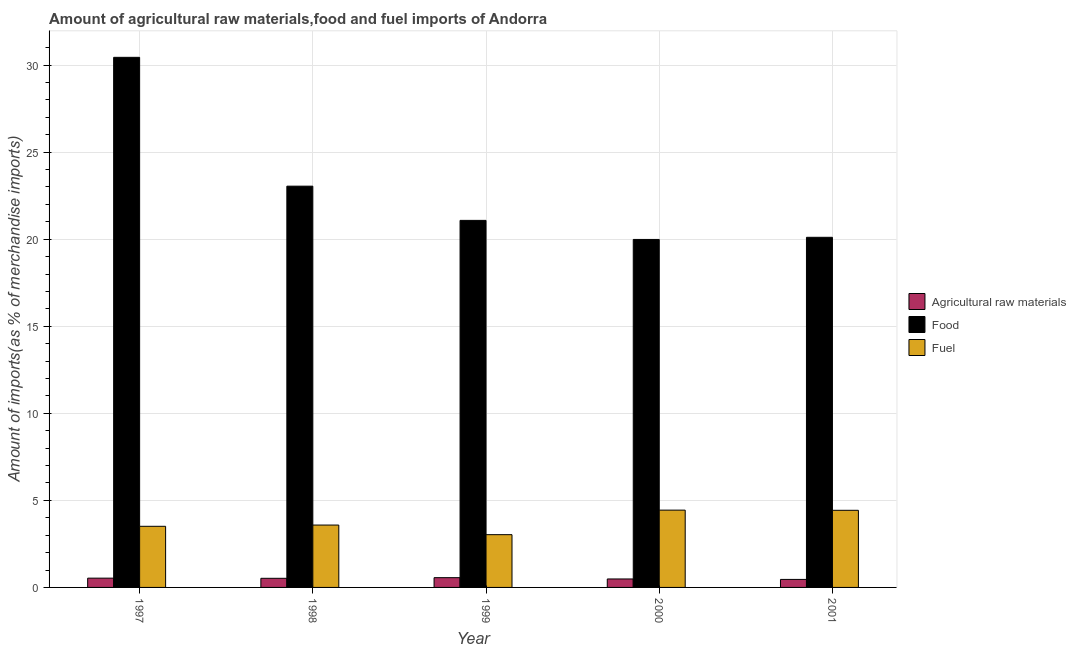How many bars are there on the 3rd tick from the left?
Provide a succinct answer. 3. In how many cases, is the number of bars for a given year not equal to the number of legend labels?
Your response must be concise. 0. What is the percentage of raw materials imports in 2000?
Make the answer very short. 0.49. Across all years, what is the maximum percentage of raw materials imports?
Provide a short and direct response. 0.56. Across all years, what is the minimum percentage of raw materials imports?
Your response must be concise. 0.46. In which year was the percentage of fuel imports minimum?
Your response must be concise. 1999. What is the total percentage of food imports in the graph?
Provide a short and direct response. 114.67. What is the difference between the percentage of raw materials imports in 1999 and that in 2000?
Provide a succinct answer. 0.07. What is the difference between the percentage of raw materials imports in 2000 and the percentage of fuel imports in 1999?
Ensure brevity in your answer.  -0.07. What is the average percentage of fuel imports per year?
Your answer should be very brief. 3.8. In how many years, is the percentage of fuel imports greater than 28 %?
Keep it short and to the point. 0. What is the ratio of the percentage of fuel imports in 1998 to that in 2001?
Provide a succinct answer. 0.81. Is the percentage of raw materials imports in 1997 less than that in 2001?
Your response must be concise. No. What is the difference between the highest and the second highest percentage of raw materials imports?
Your answer should be very brief. 0.03. What is the difference between the highest and the lowest percentage of raw materials imports?
Ensure brevity in your answer.  0.1. In how many years, is the percentage of food imports greater than the average percentage of food imports taken over all years?
Give a very brief answer. 2. Is the sum of the percentage of food imports in 2000 and 2001 greater than the maximum percentage of raw materials imports across all years?
Offer a very short reply. Yes. What does the 3rd bar from the left in 1997 represents?
Provide a short and direct response. Fuel. What does the 1st bar from the right in 1999 represents?
Offer a terse response. Fuel. How many bars are there?
Your answer should be compact. 15. How many years are there in the graph?
Provide a short and direct response. 5. What is the difference between two consecutive major ticks on the Y-axis?
Offer a terse response. 5. Does the graph contain grids?
Your response must be concise. Yes. Where does the legend appear in the graph?
Provide a short and direct response. Center right. What is the title of the graph?
Offer a terse response. Amount of agricultural raw materials,food and fuel imports of Andorra. Does "Ages 0-14" appear as one of the legend labels in the graph?
Give a very brief answer. No. What is the label or title of the X-axis?
Make the answer very short. Year. What is the label or title of the Y-axis?
Make the answer very short. Amount of imports(as % of merchandise imports). What is the Amount of imports(as % of merchandise imports) of Agricultural raw materials in 1997?
Ensure brevity in your answer.  0.53. What is the Amount of imports(as % of merchandise imports) of Food in 1997?
Ensure brevity in your answer.  30.45. What is the Amount of imports(as % of merchandise imports) in Fuel in 1997?
Give a very brief answer. 3.51. What is the Amount of imports(as % of merchandise imports) in Agricultural raw materials in 1998?
Your response must be concise. 0.52. What is the Amount of imports(as % of merchandise imports) in Food in 1998?
Offer a very short reply. 23.05. What is the Amount of imports(as % of merchandise imports) of Fuel in 1998?
Ensure brevity in your answer.  3.58. What is the Amount of imports(as % of merchandise imports) in Agricultural raw materials in 1999?
Offer a terse response. 0.56. What is the Amount of imports(as % of merchandise imports) in Food in 1999?
Your response must be concise. 21.08. What is the Amount of imports(as % of merchandise imports) in Fuel in 1999?
Make the answer very short. 3.03. What is the Amount of imports(as % of merchandise imports) in Agricultural raw materials in 2000?
Your response must be concise. 0.49. What is the Amount of imports(as % of merchandise imports) of Food in 2000?
Your response must be concise. 19.99. What is the Amount of imports(as % of merchandise imports) of Fuel in 2000?
Provide a succinct answer. 4.44. What is the Amount of imports(as % of merchandise imports) in Agricultural raw materials in 2001?
Your response must be concise. 0.46. What is the Amount of imports(as % of merchandise imports) in Food in 2001?
Your answer should be compact. 20.11. What is the Amount of imports(as % of merchandise imports) in Fuel in 2001?
Keep it short and to the point. 4.43. Across all years, what is the maximum Amount of imports(as % of merchandise imports) of Agricultural raw materials?
Your response must be concise. 0.56. Across all years, what is the maximum Amount of imports(as % of merchandise imports) of Food?
Provide a succinct answer. 30.45. Across all years, what is the maximum Amount of imports(as % of merchandise imports) of Fuel?
Your answer should be compact. 4.44. Across all years, what is the minimum Amount of imports(as % of merchandise imports) in Agricultural raw materials?
Your answer should be very brief. 0.46. Across all years, what is the minimum Amount of imports(as % of merchandise imports) in Food?
Ensure brevity in your answer.  19.99. Across all years, what is the minimum Amount of imports(as % of merchandise imports) in Fuel?
Give a very brief answer. 3.03. What is the total Amount of imports(as % of merchandise imports) of Agricultural raw materials in the graph?
Provide a succinct answer. 2.56. What is the total Amount of imports(as % of merchandise imports) of Food in the graph?
Offer a terse response. 114.67. What is the total Amount of imports(as % of merchandise imports) in Fuel in the graph?
Offer a terse response. 18.99. What is the difference between the Amount of imports(as % of merchandise imports) in Agricultural raw materials in 1997 and that in 1998?
Provide a succinct answer. 0.01. What is the difference between the Amount of imports(as % of merchandise imports) in Food in 1997 and that in 1998?
Your response must be concise. 7.4. What is the difference between the Amount of imports(as % of merchandise imports) of Fuel in 1997 and that in 1998?
Give a very brief answer. -0.07. What is the difference between the Amount of imports(as % of merchandise imports) in Agricultural raw materials in 1997 and that in 1999?
Your response must be concise. -0.03. What is the difference between the Amount of imports(as % of merchandise imports) in Food in 1997 and that in 1999?
Offer a very short reply. 9.36. What is the difference between the Amount of imports(as % of merchandise imports) in Fuel in 1997 and that in 1999?
Keep it short and to the point. 0.48. What is the difference between the Amount of imports(as % of merchandise imports) in Agricultural raw materials in 1997 and that in 2000?
Provide a short and direct response. 0.05. What is the difference between the Amount of imports(as % of merchandise imports) in Food in 1997 and that in 2000?
Your answer should be very brief. 10.46. What is the difference between the Amount of imports(as % of merchandise imports) of Fuel in 1997 and that in 2000?
Your answer should be very brief. -0.93. What is the difference between the Amount of imports(as % of merchandise imports) in Agricultural raw materials in 1997 and that in 2001?
Provide a short and direct response. 0.07. What is the difference between the Amount of imports(as % of merchandise imports) in Food in 1997 and that in 2001?
Offer a terse response. 10.34. What is the difference between the Amount of imports(as % of merchandise imports) in Fuel in 1997 and that in 2001?
Keep it short and to the point. -0.92. What is the difference between the Amount of imports(as % of merchandise imports) of Agricultural raw materials in 1998 and that in 1999?
Keep it short and to the point. -0.04. What is the difference between the Amount of imports(as % of merchandise imports) of Food in 1998 and that in 1999?
Provide a short and direct response. 1.97. What is the difference between the Amount of imports(as % of merchandise imports) in Fuel in 1998 and that in 1999?
Provide a succinct answer. 0.55. What is the difference between the Amount of imports(as % of merchandise imports) in Agricultural raw materials in 1998 and that in 2000?
Offer a very short reply. 0.04. What is the difference between the Amount of imports(as % of merchandise imports) in Food in 1998 and that in 2000?
Provide a short and direct response. 3.06. What is the difference between the Amount of imports(as % of merchandise imports) in Fuel in 1998 and that in 2000?
Make the answer very short. -0.86. What is the difference between the Amount of imports(as % of merchandise imports) of Agricultural raw materials in 1998 and that in 2001?
Your answer should be very brief. 0.06. What is the difference between the Amount of imports(as % of merchandise imports) in Food in 1998 and that in 2001?
Provide a succinct answer. 2.94. What is the difference between the Amount of imports(as % of merchandise imports) of Fuel in 1998 and that in 2001?
Offer a terse response. -0.85. What is the difference between the Amount of imports(as % of merchandise imports) of Agricultural raw materials in 1999 and that in 2000?
Make the answer very short. 0.07. What is the difference between the Amount of imports(as % of merchandise imports) of Food in 1999 and that in 2000?
Ensure brevity in your answer.  1.09. What is the difference between the Amount of imports(as % of merchandise imports) in Fuel in 1999 and that in 2000?
Keep it short and to the point. -1.41. What is the difference between the Amount of imports(as % of merchandise imports) of Agricultural raw materials in 1999 and that in 2001?
Provide a short and direct response. 0.1. What is the difference between the Amount of imports(as % of merchandise imports) in Food in 1999 and that in 2001?
Provide a short and direct response. 0.97. What is the difference between the Amount of imports(as % of merchandise imports) in Fuel in 1999 and that in 2001?
Provide a succinct answer. -1.4. What is the difference between the Amount of imports(as % of merchandise imports) of Agricultural raw materials in 2000 and that in 2001?
Your answer should be compact. 0.03. What is the difference between the Amount of imports(as % of merchandise imports) of Food in 2000 and that in 2001?
Offer a very short reply. -0.12. What is the difference between the Amount of imports(as % of merchandise imports) in Fuel in 2000 and that in 2001?
Offer a very short reply. 0.01. What is the difference between the Amount of imports(as % of merchandise imports) in Agricultural raw materials in 1997 and the Amount of imports(as % of merchandise imports) in Food in 1998?
Your answer should be very brief. -22.51. What is the difference between the Amount of imports(as % of merchandise imports) in Agricultural raw materials in 1997 and the Amount of imports(as % of merchandise imports) in Fuel in 1998?
Provide a short and direct response. -3.05. What is the difference between the Amount of imports(as % of merchandise imports) in Food in 1997 and the Amount of imports(as % of merchandise imports) in Fuel in 1998?
Keep it short and to the point. 26.86. What is the difference between the Amount of imports(as % of merchandise imports) in Agricultural raw materials in 1997 and the Amount of imports(as % of merchandise imports) in Food in 1999?
Provide a short and direct response. -20.55. What is the difference between the Amount of imports(as % of merchandise imports) of Agricultural raw materials in 1997 and the Amount of imports(as % of merchandise imports) of Fuel in 1999?
Offer a terse response. -2.5. What is the difference between the Amount of imports(as % of merchandise imports) in Food in 1997 and the Amount of imports(as % of merchandise imports) in Fuel in 1999?
Provide a short and direct response. 27.41. What is the difference between the Amount of imports(as % of merchandise imports) of Agricultural raw materials in 1997 and the Amount of imports(as % of merchandise imports) of Food in 2000?
Make the answer very short. -19.45. What is the difference between the Amount of imports(as % of merchandise imports) of Agricultural raw materials in 1997 and the Amount of imports(as % of merchandise imports) of Fuel in 2000?
Provide a short and direct response. -3.91. What is the difference between the Amount of imports(as % of merchandise imports) of Food in 1997 and the Amount of imports(as % of merchandise imports) of Fuel in 2000?
Make the answer very short. 26.01. What is the difference between the Amount of imports(as % of merchandise imports) in Agricultural raw materials in 1997 and the Amount of imports(as % of merchandise imports) in Food in 2001?
Your answer should be very brief. -19.58. What is the difference between the Amount of imports(as % of merchandise imports) in Agricultural raw materials in 1997 and the Amount of imports(as % of merchandise imports) in Fuel in 2001?
Offer a terse response. -3.9. What is the difference between the Amount of imports(as % of merchandise imports) of Food in 1997 and the Amount of imports(as % of merchandise imports) of Fuel in 2001?
Make the answer very short. 26.02. What is the difference between the Amount of imports(as % of merchandise imports) of Agricultural raw materials in 1998 and the Amount of imports(as % of merchandise imports) of Food in 1999?
Your answer should be very brief. -20.56. What is the difference between the Amount of imports(as % of merchandise imports) in Agricultural raw materials in 1998 and the Amount of imports(as % of merchandise imports) in Fuel in 1999?
Keep it short and to the point. -2.51. What is the difference between the Amount of imports(as % of merchandise imports) of Food in 1998 and the Amount of imports(as % of merchandise imports) of Fuel in 1999?
Your answer should be very brief. 20.02. What is the difference between the Amount of imports(as % of merchandise imports) in Agricultural raw materials in 1998 and the Amount of imports(as % of merchandise imports) in Food in 2000?
Your answer should be very brief. -19.46. What is the difference between the Amount of imports(as % of merchandise imports) of Agricultural raw materials in 1998 and the Amount of imports(as % of merchandise imports) of Fuel in 2000?
Ensure brevity in your answer.  -3.92. What is the difference between the Amount of imports(as % of merchandise imports) of Food in 1998 and the Amount of imports(as % of merchandise imports) of Fuel in 2000?
Make the answer very short. 18.61. What is the difference between the Amount of imports(as % of merchandise imports) in Agricultural raw materials in 1998 and the Amount of imports(as % of merchandise imports) in Food in 2001?
Provide a succinct answer. -19.58. What is the difference between the Amount of imports(as % of merchandise imports) in Agricultural raw materials in 1998 and the Amount of imports(as % of merchandise imports) in Fuel in 2001?
Your answer should be compact. -3.91. What is the difference between the Amount of imports(as % of merchandise imports) of Food in 1998 and the Amount of imports(as % of merchandise imports) of Fuel in 2001?
Keep it short and to the point. 18.62. What is the difference between the Amount of imports(as % of merchandise imports) of Agricultural raw materials in 1999 and the Amount of imports(as % of merchandise imports) of Food in 2000?
Offer a very short reply. -19.43. What is the difference between the Amount of imports(as % of merchandise imports) of Agricultural raw materials in 1999 and the Amount of imports(as % of merchandise imports) of Fuel in 2000?
Your answer should be very brief. -3.88. What is the difference between the Amount of imports(as % of merchandise imports) in Food in 1999 and the Amount of imports(as % of merchandise imports) in Fuel in 2000?
Keep it short and to the point. 16.64. What is the difference between the Amount of imports(as % of merchandise imports) of Agricultural raw materials in 1999 and the Amount of imports(as % of merchandise imports) of Food in 2001?
Provide a short and direct response. -19.55. What is the difference between the Amount of imports(as % of merchandise imports) in Agricultural raw materials in 1999 and the Amount of imports(as % of merchandise imports) in Fuel in 2001?
Your response must be concise. -3.87. What is the difference between the Amount of imports(as % of merchandise imports) in Food in 1999 and the Amount of imports(as % of merchandise imports) in Fuel in 2001?
Keep it short and to the point. 16.65. What is the difference between the Amount of imports(as % of merchandise imports) of Agricultural raw materials in 2000 and the Amount of imports(as % of merchandise imports) of Food in 2001?
Provide a succinct answer. -19.62. What is the difference between the Amount of imports(as % of merchandise imports) of Agricultural raw materials in 2000 and the Amount of imports(as % of merchandise imports) of Fuel in 2001?
Your answer should be very brief. -3.94. What is the difference between the Amount of imports(as % of merchandise imports) in Food in 2000 and the Amount of imports(as % of merchandise imports) in Fuel in 2001?
Your response must be concise. 15.56. What is the average Amount of imports(as % of merchandise imports) in Agricultural raw materials per year?
Your answer should be very brief. 0.51. What is the average Amount of imports(as % of merchandise imports) of Food per year?
Your answer should be compact. 22.93. What is the average Amount of imports(as % of merchandise imports) in Fuel per year?
Offer a very short reply. 3.8. In the year 1997, what is the difference between the Amount of imports(as % of merchandise imports) of Agricultural raw materials and Amount of imports(as % of merchandise imports) of Food?
Your answer should be very brief. -29.91. In the year 1997, what is the difference between the Amount of imports(as % of merchandise imports) of Agricultural raw materials and Amount of imports(as % of merchandise imports) of Fuel?
Offer a terse response. -2.98. In the year 1997, what is the difference between the Amount of imports(as % of merchandise imports) in Food and Amount of imports(as % of merchandise imports) in Fuel?
Your response must be concise. 26.94. In the year 1998, what is the difference between the Amount of imports(as % of merchandise imports) of Agricultural raw materials and Amount of imports(as % of merchandise imports) of Food?
Provide a succinct answer. -22.52. In the year 1998, what is the difference between the Amount of imports(as % of merchandise imports) in Agricultural raw materials and Amount of imports(as % of merchandise imports) in Fuel?
Your answer should be compact. -3.06. In the year 1998, what is the difference between the Amount of imports(as % of merchandise imports) in Food and Amount of imports(as % of merchandise imports) in Fuel?
Offer a terse response. 19.46. In the year 1999, what is the difference between the Amount of imports(as % of merchandise imports) of Agricultural raw materials and Amount of imports(as % of merchandise imports) of Food?
Your answer should be compact. -20.52. In the year 1999, what is the difference between the Amount of imports(as % of merchandise imports) in Agricultural raw materials and Amount of imports(as % of merchandise imports) in Fuel?
Offer a very short reply. -2.47. In the year 1999, what is the difference between the Amount of imports(as % of merchandise imports) of Food and Amount of imports(as % of merchandise imports) of Fuel?
Keep it short and to the point. 18.05. In the year 2000, what is the difference between the Amount of imports(as % of merchandise imports) of Agricultural raw materials and Amount of imports(as % of merchandise imports) of Food?
Your response must be concise. -19.5. In the year 2000, what is the difference between the Amount of imports(as % of merchandise imports) of Agricultural raw materials and Amount of imports(as % of merchandise imports) of Fuel?
Provide a short and direct response. -3.95. In the year 2000, what is the difference between the Amount of imports(as % of merchandise imports) of Food and Amount of imports(as % of merchandise imports) of Fuel?
Give a very brief answer. 15.55. In the year 2001, what is the difference between the Amount of imports(as % of merchandise imports) of Agricultural raw materials and Amount of imports(as % of merchandise imports) of Food?
Keep it short and to the point. -19.65. In the year 2001, what is the difference between the Amount of imports(as % of merchandise imports) of Agricultural raw materials and Amount of imports(as % of merchandise imports) of Fuel?
Provide a succinct answer. -3.97. In the year 2001, what is the difference between the Amount of imports(as % of merchandise imports) of Food and Amount of imports(as % of merchandise imports) of Fuel?
Keep it short and to the point. 15.68. What is the ratio of the Amount of imports(as % of merchandise imports) in Agricultural raw materials in 1997 to that in 1998?
Give a very brief answer. 1.02. What is the ratio of the Amount of imports(as % of merchandise imports) in Food in 1997 to that in 1998?
Give a very brief answer. 1.32. What is the ratio of the Amount of imports(as % of merchandise imports) of Agricultural raw materials in 1997 to that in 1999?
Your answer should be compact. 0.95. What is the ratio of the Amount of imports(as % of merchandise imports) of Food in 1997 to that in 1999?
Keep it short and to the point. 1.44. What is the ratio of the Amount of imports(as % of merchandise imports) in Fuel in 1997 to that in 1999?
Keep it short and to the point. 1.16. What is the ratio of the Amount of imports(as % of merchandise imports) of Agricultural raw materials in 1997 to that in 2000?
Your response must be concise. 1.1. What is the ratio of the Amount of imports(as % of merchandise imports) of Food in 1997 to that in 2000?
Make the answer very short. 1.52. What is the ratio of the Amount of imports(as % of merchandise imports) of Fuel in 1997 to that in 2000?
Make the answer very short. 0.79. What is the ratio of the Amount of imports(as % of merchandise imports) of Agricultural raw materials in 1997 to that in 2001?
Your response must be concise. 1.16. What is the ratio of the Amount of imports(as % of merchandise imports) of Food in 1997 to that in 2001?
Ensure brevity in your answer.  1.51. What is the ratio of the Amount of imports(as % of merchandise imports) in Fuel in 1997 to that in 2001?
Provide a succinct answer. 0.79. What is the ratio of the Amount of imports(as % of merchandise imports) in Agricultural raw materials in 1998 to that in 1999?
Your answer should be very brief. 0.93. What is the ratio of the Amount of imports(as % of merchandise imports) in Food in 1998 to that in 1999?
Your answer should be compact. 1.09. What is the ratio of the Amount of imports(as % of merchandise imports) in Fuel in 1998 to that in 1999?
Your answer should be compact. 1.18. What is the ratio of the Amount of imports(as % of merchandise imports) of Agricultural raw materials in 1998 to that in 2000?
Your answer should be compact. 1.08. What is the ratio of the Amount of imports(as % of merchandise imports) of Food in 1998 to that in 2000?
Your answer should be compact. 1.15. What is the ratio of the Amount of imports(as % of merchandise imports) in Fuel in 1998 to that in 2000?
Offer a very short reply. 0.81. What is the ratio of the Amount of imports(as % of merchandise imports) in Agricultural raw materials in 1998 to that in 2001?
Keep it short and to the point. 1.14. What is the ratio of the Amount of imports(as % of merchandise imports) in Food in 1998 to that in 2001?
Your response must be concise. 1.15. What is the ratio of the Amount of imports(as % of merchandise imports) of Fuel in 1998 to that in 2001?
Your answer should be compact. 0.81. What is the ratio of the Amount of imports(as % of merchandise imports) of Agricultural raw materials in 1999 to that in 2000?
Give a very brief answer. 1.15. What is the ratio of the Amount of imports(as % of merchandise imports) in Food in 1999 to that in 2000?
Keep it short and to the point. 1.05. What is the ratio of the Amount of imports(as % of merchandise imports) of Fuel in 1999 to that in 2000?
Ensure brevity in your answer.  0.68. What is the ratio of the Amount of imports(as % of merchandise imports) in Agricultural raw materials in 1999 to that in 2001?
Provide a succinct answer. 1.22. What is the ratio of the Amount of imports(as % of merchandise imports) of Food in 1999 to that in 2001?
Keep it short and to the point. 1.05. What is the ratio of the Amount of imports(as % of merchandise imports) in Fuel in 1999 to that in 2001?
Provide a short and direct response. 0.68. What is the ratio of the Amount of imports(as % of merchandise imports) in Agricultural raw materials in 2000 to that in 2001?
Your answer should be compact. 1.06. What is the ratio of the Amount of imports(as % of merchandise imports) of Food in 2000 to that in 2001?
Offer a terse response. 0.99. What is the ratio of the Amount of imports(as % of merchandise imports) of Fuel in 2000 to that in 2001?
Your answer should be compact. 1. What is the difference between the highest and the second highest Amount of imports(as % of merchandise imports) in Agricultural raw materials?
Ensure brevity in your answer.  0.03. What is the difference between the highest and the second highest Amount of imports(as % of merchandise imports) of Food?
Keep it short and to the point. 7.4. What is the difference between the highest and the second highest Amount of imports(as % of merchandise imports) in Fuel?
Offer a very short reply. 0.01. What is the difference between the highest and the lowest Amount of imports(as % of merchandise imports) in Agricultural raw materials?
Your answer should be very brief. 0.1. What is the difference between the highest and the lowest Amount of imports(as % of merchandise imports) of Food?
Give a very brief answer. 10.46. What is the difference between the highest and the lowest Amount of imports(as % of merchandise imports) in Fuel?
Provide a succinct answer. 1.41. 